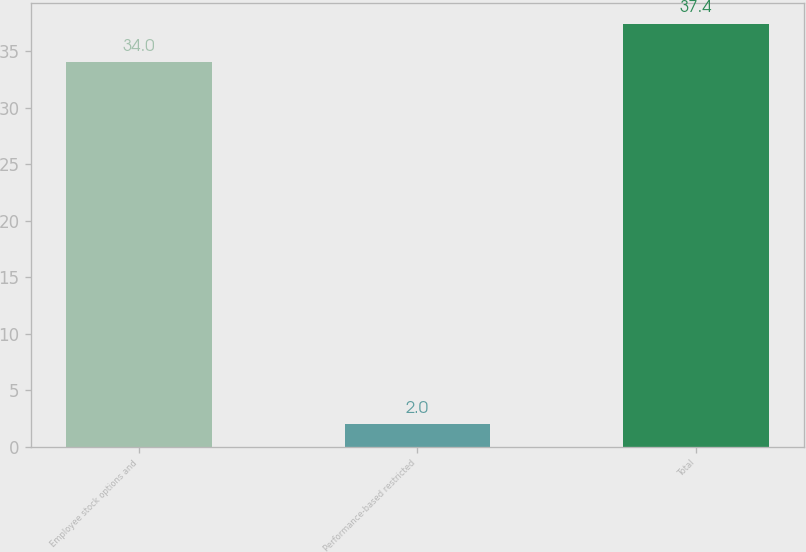Convert chart to OTSL. <chart><loc_0><loc_0><loc_500><loc_500><bar_chart><fcel>Employee stock options and<fcel>Performance-based restricted<fcel>Total<nl><fcel>34<fcel>2<fcel>37.4<nl></chart> 